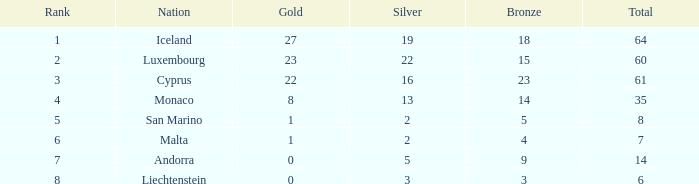With over 2 silver medals, what is the number of bronzes for iceland? 18.0. 